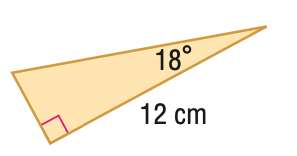Answer the mathemtical geometry problem and directly provide the correct option letter.
Question: Find the perimeter of the triangle. Round to the nearest hundredth.
Choices: A: 27.31 B: 28.52 C: 60.34 D: 61.55 B 